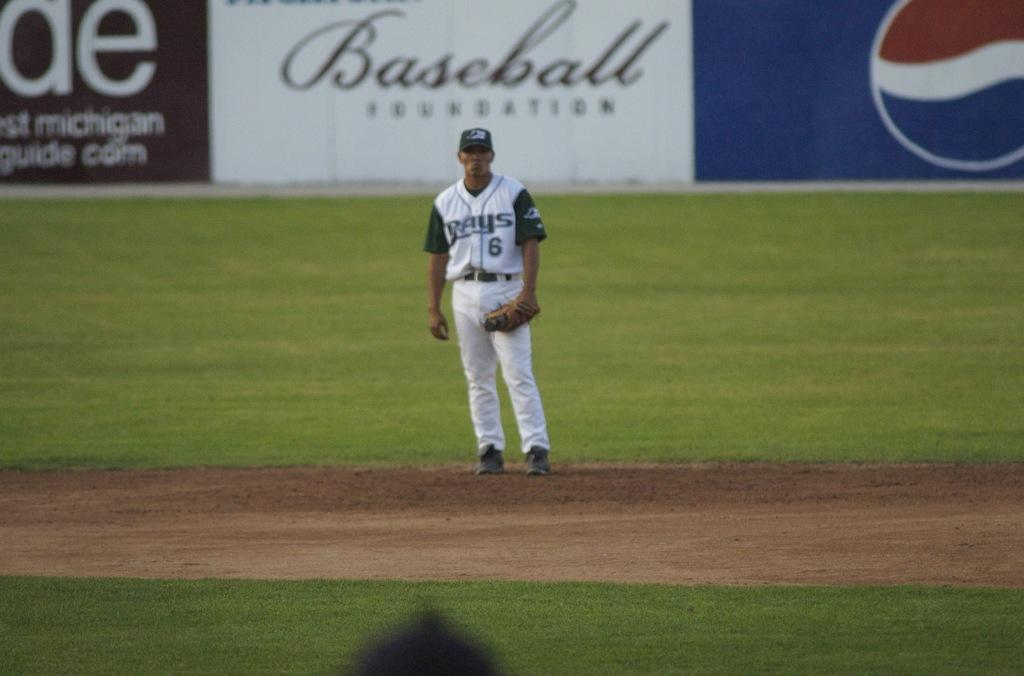<image>
Summarize the visual content of the image. A baseball field where a man with a number 6 on his jersey is staring at the camera 